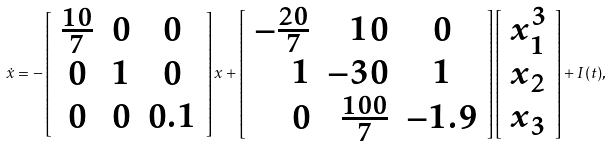Convert formula to latex. <formula><loc_0><loc_0><loc_500><loc_500>\dot { x } = - \left [ \begin{array} { c c c } \frac { 1 0 } { 7 } & 0 & 0 \\ 0 & 1 & 0 \\ 0 & 0 & 0 . 1 \end{array} \right ] x + \left [ \begin{array} { r r c } - \frac { 2 0 } { 7 } & 1 0 & 0 \\ 1 & - 3 0 & 1 \\ 0 & \frac { 1 0 0 } { 7 } & - 1 . 9 \end{array} \right ] \left [ \begin{array} { l } x _ { 1 } ^ { 3 } \\ x _ { 2 } \\ x _ { 3 } \end{array} \right ] + I ( t ) ,</formula> 